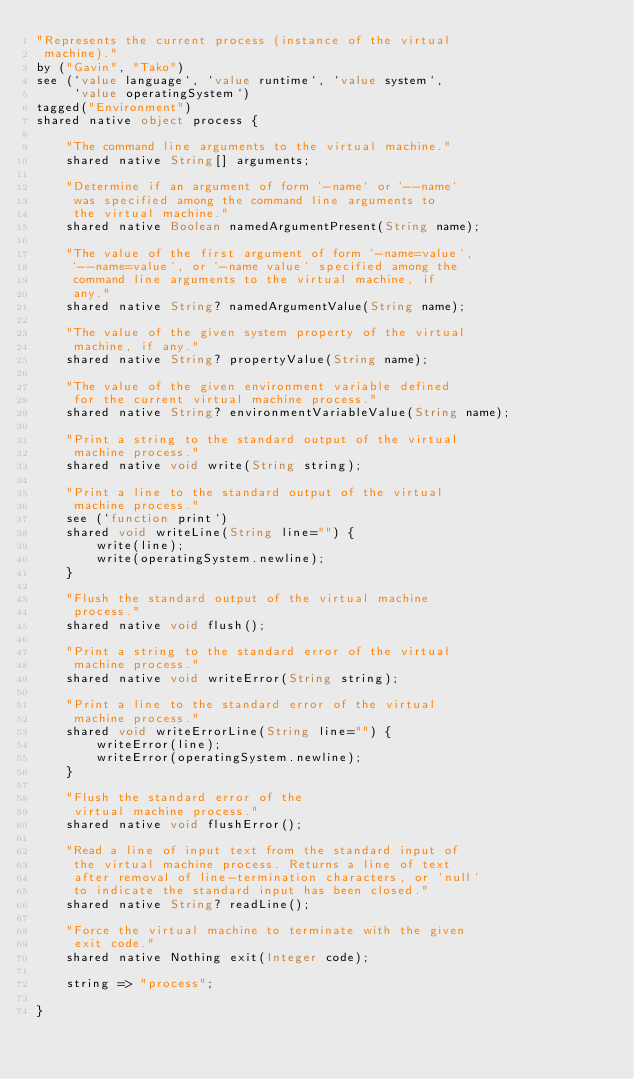Convert code to text. <code><loc_0><loc_0><loc_500><loc_500><_Ceylon_>"Represents the current process (instance of the virtual
 machine)."
by ("Gavin", "Tako")
see (`value language`, `value runtime`, `value system`,
     `value operatingSystem`)
tagged("Environment")
shared native object process {
    
    "The command line arguments to the virtual machine."
    shared native String[] arguments;
    
    "Determine if an argument of form `-name` or `--name` 
     was specified among the command line arguments to 
     the virtual machine."
    shared native Boolean namedArgumentPresent(String name);

    "The value of the first argument of form `-name=value`, 
     `--name=value`, or `-name value` specified among the 
     command line arguments to the virtual machine, if
     any."
    shared native String? namedArgumentValue(String name);

    "The value of the given system property of the virtual
     machine, if any."
    shared native String? propertyValue(String name);

    "The value of the given environment variable defined 
     for the current virtual machine process."
    shared native String? environmentVariableValue(String name);
    
    "Print a string to the standard output of the virtual
     machine process."
    shared native void write(String string);
    
    "Print a line to the standard output of the virtual 
     machine process."
    see (`function print`)
    shared void writeLine(String line="") { 
        write(line);
        write(operatingSystem.newline); 
    }
    
    "Flush the standard output of the virtual machine 
     process."
    shared native void flush();
    
    "Print a string to the standard error of the virtual 
     machine process."
    shared native void writeError(String string);
    
    "Print a line to the standard error of the virtual 
     machine process."
    shared void writeErrorLine(String line="") { 
        writeError(line);
        writeError(operatingSystem.newline);
    }
    
    "Flush the standard error of the 
     virtual machine process."
    shared native void flushError();
    
    "Read a line of input text from the standard input of 
     the virtual machine process. Returns a line of text 
     after removal of line-termination characters, or `null`
     to indicate the standard input has been closed."
    shared native String? readLine();
    
    "Force the virtual machine to terminate with the given
     exit code."
    shared native Nothing exit(Integer code);
    
    string => "process";
    
}
</code> 